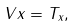<formula> <loc_0><loc_0><loc_500><loc_500>V x = T _ { x } ,</formula> 